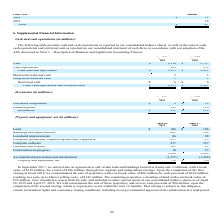According to Netapp's financial document, What agreement did the company enter in September 2017? to sell certain land and buildings located in Sunnyvale, California. The document states: "In September 2017, we entered into an agreement to sell certain land and buildings located in Sunnyvale, California, with a book value of $118 million..." Also, What was the amount of buildings and improvements in 2019? According to the financial document, 605 (in millions). The relevant text states: "Buildings and improvements 605 594..." Also, Which years does the table provide information for net property and equipment? The document shows two values: 2019 and 2018. From the document: "2019 2018..." Also, How many years did buildings and improvements exceed $600 million? Based on the analysis, there are 1 instances. The counting process: 2019. Also, can you calculate: What was the change in Computer, production, engineering and other equipment between 2018 and 2019? Based on the calculation: 817-733, the result is 84 (in millions). This is based on the information: ", production, engineering and other equipment 817 733 uter, production, engineering and other equipment 817 733..." The key data points involved are: 733, 817. Also, can you calculate: What was the percentage change in the amount of leasehold improvements between 2018 and 2019? To answer this question, I need to perform calculations using the financial data. The calculation is: (86-88)/88, which equals -2.27 (percentage). This is based on the information: "Leasehold improvements 86 88 Leasehold improvements 86 88..." The key data points involved are: 86, 88. 